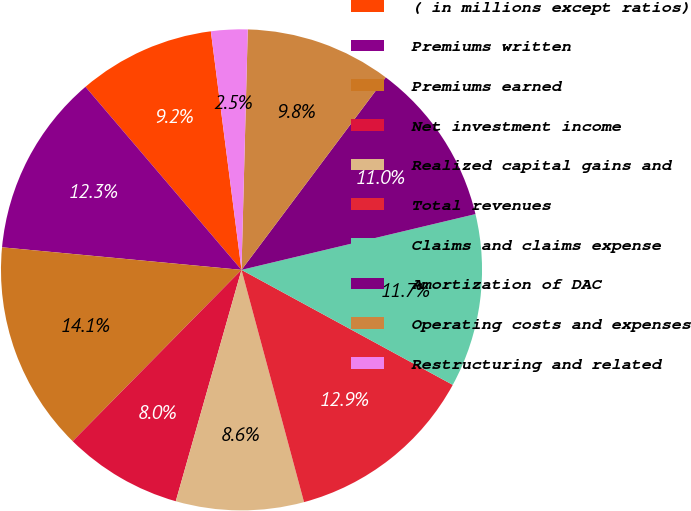<chart> <loc_0><loc_0><loc_500><loc_500><pie_chart><fcel>( in millions except ratios)<fcel>Premiums written<fcel>Premiums earned<fcel>Net investment income<fcel>Realized capital gains and<fcel>Total revenues<fcel>Claims and claims expense<fcel>Amortization of DAC<fcel>Operating costs and expenses<fcel>Restructuring and related<nl><fcel>9.2%<fcel>12.27%<fcel>14.11%<fcel>7.98%<fcel>8.59%<fcel>12.88%<fcel>11.66%<fcel>11.04%<fcel>9.82%<fcel>2.45%<nl></chart> 